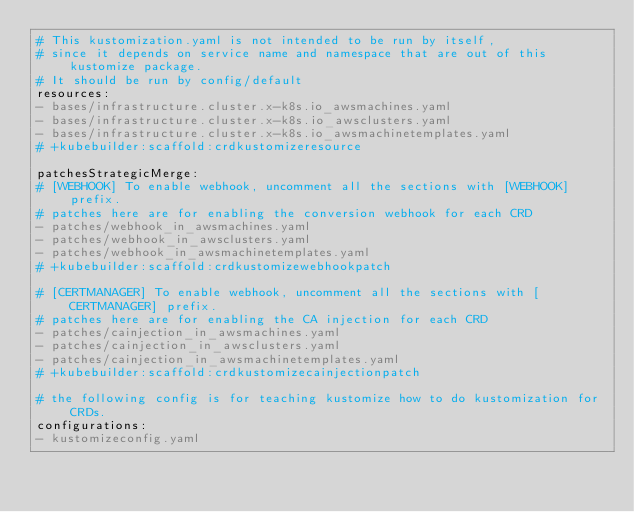<code> <loc_0><loc_0><loc_500><loc_500><_YAML_># This kustomization.yaml is not intended to be run by itself,
# since it depends on service name and namespace that are out of this kustomize package.
# It should be run by config/default
resources:
- bases/infrastructure.cluster.x-k8s.io_awsmachines.yaml
- bases/infrastructure.cluster.x-k8s.io_awsclusters.yaml
- bases/infrastructure.cluster.x-k8s.io_awsmachinetemplates.yaml
# +kubebuilder:scaffold:crdkustomizeresource

patchesStrategicMerge:
# [WEBHOOK] To enable webhook, uncomment all the sections with [WEBHOOK] prefix.
# patches here are for enabling the conversion webhook for each CRD
- patches/webhook_in_awsmachines.yaml
- patches/webhook_in_awsclusters.yaml
- patches/webhook_in_awsmachinetemplates.yaml
# +kubebuilder:scaffold:crdkustomizewebhookpatch

# [CERTMANAGER] To enable webhook, uncomment all the sections with [CERTMANAGER] prefix.
# patches here are for enabling the CA injection for each CRD
- patches/cainjection_in_awsmachines.yaml
- patches/cainjection_in_awsclusters.yaml
- patches/cainjection_in_awsmachinetemplates.yaml
# +kubebuilder:scaffold:crdkustomizecainjectionpatch

# the following config is for teaching kustomize how to do kustomization for CRDs.
configurations:
- kustomizeconfig.yaml
</code> 